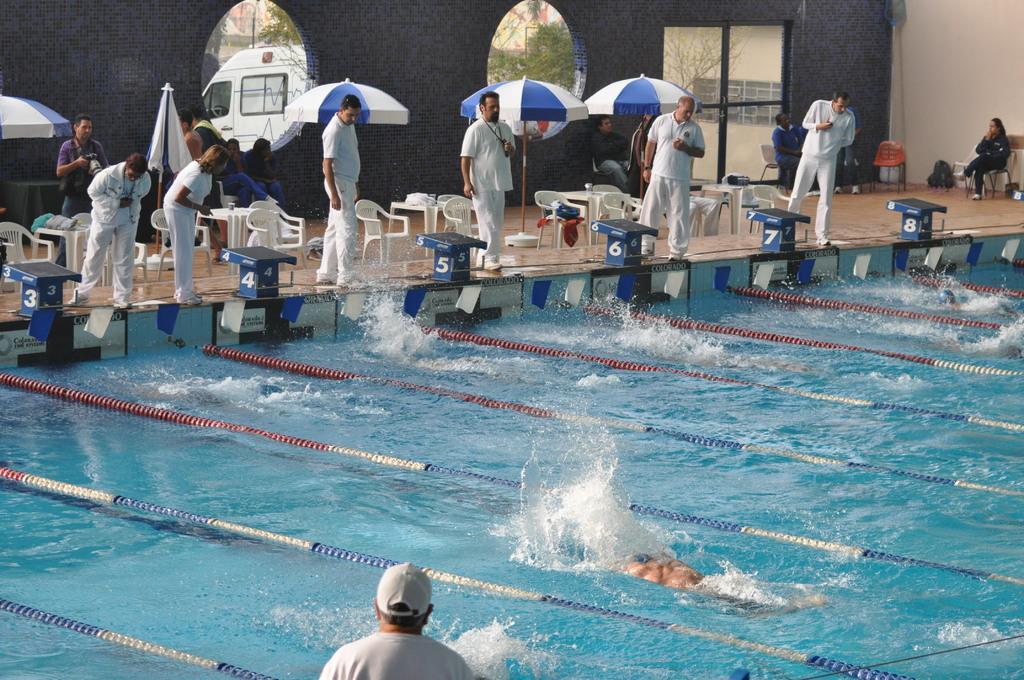Could you give a brief overview of what you see in this image? This image consists of a swimming pool. In which there are few persons swimming. In the front, there are few persons standing and wearing white dresses. In the background, we can see the umbrellas and a wall along with windows and a door. Through the window, we can see a vehicle in white color. And there are many chairs on the floor. At the bottom, there is water. 